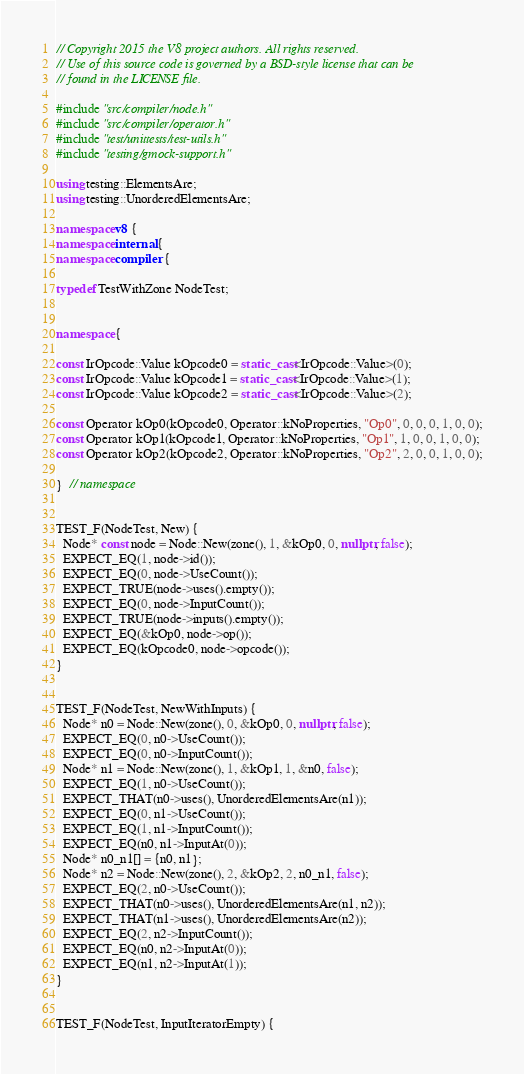Convert code to text. <code><loc_0><loc_0><loc_500><loc_500><_C++_>// Copyright 2015 the V8 project authors. All rights reserved.
// Use of this source code is governed by a BSD-style license that can be
// found in the LICENSE file.

#include "src/compiler/node.h"
#include "src/compiler/operator.h"
#include "test/unittests/test-utils.h"
#include "testing/gmock-support.h"

using testing::ElementsAre;
using testing::UnorderedElementsAre;

namespace v8 {
namespace internal {
namespace compiler {

typedef TestWithZone NodeTest;


namespace {

const IrOpcode::Value kOpcode0 = static_cast<IrOpcode::Value>(0);
const IrOpcode::Value kOpcode1 = static_cast<IrOpcode::Value>(1);
const IrOpcode::Value kOpcode2 = static_cast<IrOpcode::Value>(2);

const Operator kOp0(kOpcode0, Operator::kNoProperties, "Op0", 0, 0, 0, 1, 0, 0);
const Operator kOp1(kOpcode1, Operator::kNoProperties, "Op1", 1, 0, 0, 1, 0, 0);
const Operator kOp2(kOpcode2, Operator::kNoProperties, "Op2", 2, 0, 0, 1, 0, 0);

}  // namespace


TEST_F(NodeTest, New) {
  Node* const node = Node::New(zone(), 1, &kOp0, 0, nullptr, false);
  EXPECT_EQ(1, node->id());
  EXPECT_EQ(0, node->UseCount());
  EXPECT_TRUE(node->uses().empty());
  EXPECT_EQ(0, node->InputCount());
  EXPECT_TRUE(node->inputs().empty());
  EXPECT_EQ(&kOp0, node->op());
  EXPECT_EQ(kOpcode0, node->opcode());
}


TEST_F(NodeTest, NewWithInputs) {
  Node* n0 = Node::New(zone(), 0, &kOp0, 0, nullptr, false);
  EXPECT_EQ(0, n0->UseCount());
  EXPECT_EQ(0, n0->InputCount());
  Node* n1 = Node::New(zone(), 1, &kOp1, 1, &n0, false);
  EXPECT_EQ(1, n0->UseCount());
  EXPECT_THAT(n0->uses(), UnorderedElementsAre(n1));
  EXPECT_EQ(0, n1->UseCount());
  EXPECT_EQ(1, n1->InputCount());
  EXPECT_EQ(n0, n1->InputAt(0));
  Node* n0_n1[] = {n0, n1};
  Node* n2 = Node::New(zone(), 2, &kOp2, 2, n0_n1, false);
  EXPECT_EQ(2, n0->UseCount());
  EXPECT_THAT(n0->uses(), UnorderedElementsAre(n1, n2));
  EXPECT_THAT(n1->uses(), UnorderedElementsAre(n2));
  EXPECT_EQ(2, n2->InputCount());
  EXPECT_EQ(n0, n2->InputAt(0));
  EXPECT_EQ(n1, n2->InputAt(1));
}


TEST_F(NodeTest, InputIteratorEmpty) {</code> 